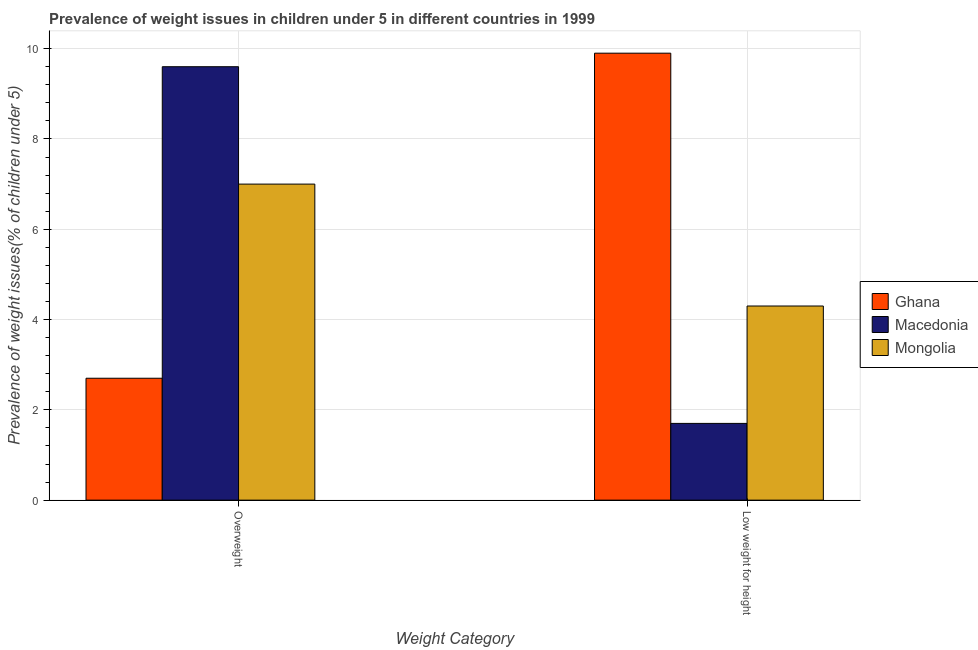How many different coloured bars are there?
Ensure brevity in your answer.  3. Are the number of bars per tick equal to the number of legend labels?
Provide a short and direct response. Yes. How many bars are there on the 2nd tick from the left?
Keep it short and to the point. 3. What is the label of the 2nd group of bars from the left?
Keep it short and to the point. Low weight for height. Across all countries, what is the maximum percentage of underweight children?
Your answer should be compact. 9.9. Across all countries, what is the minimum percentage of underweight children?
Your response must be concise. 1.7. In which country was the percentage of overweight children maximum?
Provide a short and direct response. Macedonia. In which country was the percentage of underweight children minimum?
Keep it short and to the point. Macedonia. What is the total percentage of overweight children in the graph?
Provide a short and direct response. 19.3. What is the difference between the percentage of underweight children in Macedonia and that in Mongolia?
Offer a very short reply. -2.6. What is the difference between the percentage of overweight children in Macedonia and the percentage of underweight children in Mongolia?
Provide a short and direct response. 5.3. What is the average percentage of underweight children per country?
Make the answer very short. 5.3. What is the difference between the percentage of overweight children and percentage of underweight children in Mongolia?
Your response must be concise. 2.7. What is the ratio of the percentage of overweight children in Ghana to that in Mongolia?
Offer a very short reply. 0.39. Is the percentage of underweight children in Macedonia less than that in Ghana?
Provide a short and direct response. Yes. In how many countries, is the percentage of overweight children greater than the average percentage of overweight children taken over all countries?
Your answer should be very brief. 2. What does the 2nd bar from the right in Low weight for height represents?
Your response must be concise. Macedonia. How many bars are there?
Provide a succinct answer. 6. How many countries are there in the graph?
Offer a terse response. 3. Does the graph contain any zero values?
Offer a very short reply. No. How many legend labels are there?
Ensure brevity in your answer.  3. How are the legend labels stacked?
Make the answer very short. Vertical. What is the title of the graph?
Offer a very short reply. Prevalence of weight issues in children under 5 in different countries in 1999. Does "Lower middle income" appear as one of the legend labels in the graph?
Ensure brevity in your answer.  No. What is the label or title of the X-axis?
Make the answer very short. Weight Category. What is the label or title of the Y-axis?
Provide a short and direct response. Prevalence of weight issues(% of children under 5). What is the Prevalence of weight issues(% of children under 5) of Ghana in Overweight?
Ensure brevity in your answer.  2.7. What is the Prevalence of weight issues(% of children under 5) of Macedonia in Overweight?
Your answer should be very brief. 9.6. What is the Prevalence of weight issues(% of children under 5) of Ghana in Low weight for height?
Your response must be concise. 9.9. What is the Prevalence of weight issues(% of children under 5) in Macedonia in Low weight for height?
Your answer should be compact. 1.7. What is the Prevalence of weight issues(% of children under 5) of Mongolia in Low weight for height?
Keep it short and to the point. 4.3. Across all Weight Category, what is the maximum Prevalence of weight issues(% of children under 5) in Ghana?
Your answer should be very brief. 9.9. Across all Weight Category, what is the maximum Prevalence of weight issues(% of children under 5) of Macedonia?
Your response must be concise. 9.6. Across all Weight Category, what is the minimum Prevalence of weight issues(% of children under 5) of Ghana?
Ensure brevity in your answer.  2.7. Across all Weight Category, what is the minimum Prevalence of weight issues(% of children under 5) in Macedonia?
Give a very brief answer. 1.7. Across all Weight Category, what is the minimum Prevalence of weight issues(% of children under 5) in Mongolia?
Ensure brevity in your answer.  4.3. What is the total Prevalence of weight issues(% of children under 5) of Macedonia in the graph?
Your answer should be compact. 11.3. What is the total Prevalence of weight issues(% of children under 5) in Mongolia in the graph?
Provide a short and direct response. 11.3. What is the difference between the Prevalence of weight issues(% of children under 5) of Macedonia in Overweight and that in Low weight for height?
Your answer should be compact. 7.9. What is the difference between the Prevalence of weight issues(% of children under 5) of Mongolia in Overweight and that in Low weight for height?
Offer a very short reply. 2.7. What is the average Prevalence of weight issues(% of children under 5) in Macedonia per Weight Category?
Offer a terse response. 5.65. What is the average Prevalence of weight issues(% of children under 5) of Mongolia per Weight Category?
Your answer should be compact. 5.65. What is the difference between the Prevalence of weight issues(% of children under 5) of Macedonia and Prevalence of weight issues(% of children under 5) of Mongolia in Overweight?
Ensure brevity in your answer.  2.6. What is the difference between the Prevalence of weight issues(% of children under 5) in Macedonia and Prevalence of weight issues(% of children under 5) in Mongolia in Low weight for height?
Keep it short and to the point. -2.6. What is the ratio of the Prevalence of weight issues(% of children under 5) of Ghana in Overweight to that in Low weight for height?
Offer a terse response. 0.27. What is the ratio of the Prevalence of weight issues(% of children under 5) of Macedonia in Overweight to that in Low weight for height?
Offer a terse response. 5.65. What is the ratio of the Prevalence of weight issues(% of children under 5) of Mongolia in Overweight to that in Low weight for height?
Give a very brief answer. 1.63. What is the difference between the highest and the second highest Prevalence of weight issues(% of children under 5) of Ghana?
Your answer should be very brief. 7.2. What is the difference between the highest and the lowest Prevalence of weight issues(% of children under 5) in Ghana?
Offer a terse response. 7.2. What is the difference between the highest and the lowest Prevalence of weight issues(% of children under 5) in Macedonia?
Your answer should be compact. 7.9. 